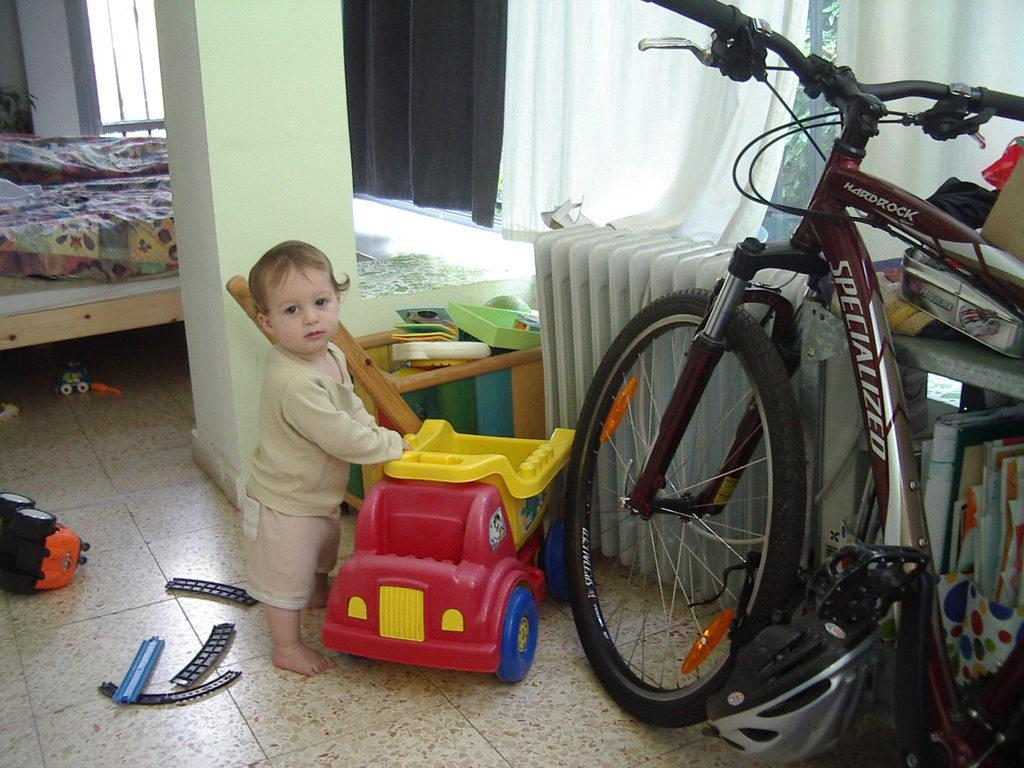Who is in the image? There is a boy in the image. What is the boy holding? The boy is holding a toy car. What color is the toy car? The toy car is red. What other object related to transportation is in the image? A bicycle is present in the image. How is the bicycle positioned in the image? The bicycle is kept aside. What else can be seen near the boy? There are other toys beside the boy. What is behind the boy? There is a pillar at the boy's back. What type of cable can be seen connecting the boy to the toy car? There is no cable present in the image connecting the boy to the toy car. 